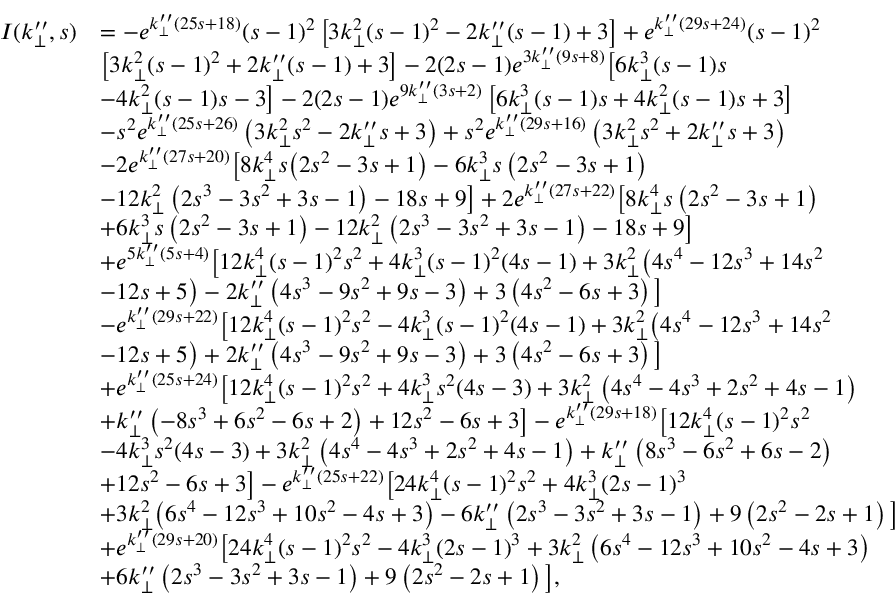Convert formula to latex. <formula><loc_0><loc_0><loc_500><loc_500>\begin{array} { r l } { I ( k _ { \perp } ^ { \prime \prime } , s ) } & { = - e ^ { k _ { \perp } ^ { \prime \prime } ( 2 5 s + 1 8 ) } ( s - 1 ) ^ { 2 } \left [ 3 k _ { \perp } ^ { 2 } ( s - 1 ) ^ { 2 } - 2 k _ { \perp } ^ { \prime \prime } ( s - 1 ) + 3 \right ] + e ^ { k _ { \perp } ^ { \prime \prime } ( 2 9 s + 2 4 ) } ( s - 1 ) ^ { 2 } } \\ & { \left [ 3 k _ { \perp } ^ { 2 } ( s - 1 ) ^ { 2 } + 2 k _ { \perp } ^ { \prime \prime } ( s - 1 ) + 3 \right ] - 2 ( 2 s - 1 ) e ^ { 3 k _ { \perp } ^ { \prime \prime } ( 9 s + 8 ) } \left [ 6 k _ { \perp } ^ { 3 } ( s - 1 ) s } \\ & { - 4 k _ { \perp } ^ { 2 } ( s - 1 ) s - 3 \right ] - 2 ( 2 s - 1 ) e ^ { 9 k _ { \perp } ^ { \prime \prime } ( 3 s + 2 ) } \left [ 6 k _ { \perp } ^ { 3 } ( s - 1 ) s + 4 k _ { \perp } ^ { 2 } ( s - 1 ) s + 3 \right ] } \\ & { - s ^ { 2 } e ^ { k _ { \perp } ^ { \prime \prime } ( 2 5 s + 2 6 ) } \left ( 3 k _ { \perp } ^ { 2 } s ^ { 2 } - 2 k _ { \perp } ^ { \prime \prime } s + 3 \right ) + s ^ { 2 } e ^ { k _ { \perp } ^ { \prime \prime } ( 2 9 s + 1 6 ) } \left ( 3 k _ { \perp } ^ { 2 } s ^ { 2 } + 2 k _ { \perp } ^ { \prime \prime } s + 3 \right ) } \\ & { - 2 e ^ { k _ { \perp } ^ { \prime \prime } ( 2 7 s + 2 0 ) } \left [ 8 k _ { \perp } ^ { 4 } s \left ( 2 s ^ { 2 } - 3 s + 1 \right ) - 6 k _ { \perp } ^ { 3 } s \left ( 2 s ^ { 2 } - 3 s + 1 \right ) } \\ & { - 1 2 k _ { \perp } ^ { 2 } \left ( 2 s ^ { 3 } - 3 s ^ { 2 } + 3 s - 1 \right ) - 1 8 s + 9 \right ] + 2 e ^ { k _ { \perp } ^ { \prime \prime } ( 2 7 s + 2 2 ) } \left [ 8 k _ { \perp } ^ { 4 } s \left ( 2 s ^ { 2 } - 3 s + 1 \right ) } \\ & { + 6 k _ { \perp } ^ { 3 } s \left ( 2 s ^ { 2 } - 3 s + 1 \right ) - 1 2 k _ { \perp } ^ { 2 } \left ( 2 s ^ { 3 } - 3 s ^ { 2 } + 3 s - 1 \right ) - 1 8 s + 9 \right ] } \\ & { + e ^ { 5 k _ { \perp } ^ { \prime \prime } ( 5 s + 4 ) } \left [ 1 2 k _ { \perp } ^ { 4 } ( s - 1 ) ^ { 2 } s ^ { 2 } + 4 k _ { \perp } ^ { 3 } ( s - 1 ) ^ { 2 } ( 4 s - 1 ) + 3 k _ { \perp } ^ { 2 } \left ( 4 s ^ { 4 } - 1 2 s ^ { 3 } + 1 4 s ^ { 2 } } \\ & { - 1 2 s + 5 \right ) - 2 k _ { \perp } ^ { \prime \prime } \left ( 4 s ^ { 3 } - 9 s ^ { 2 } + 9 s - 3 \right ) + 3 \left ( 4 s ^ { 2 } - 6 s + 3 \right ) \right ] } \\ & { - e ^ { k _ { \perp } ^ { \prime \prime } ( 2 9 s + 2 2 ) } \left [ 1 2 k _ { \perp } ^ { 4 } ( s - 1 ) ^ { 2 } s ^ { 2 } - 4 k _ { \perp } ^ { 3 } ( s - 1 ) ^ { 2 } ( 4 s - 1 ) + 3 k _ { \perp } ^ { 2 } \left ( 4 s ^ { 4 } - 1 2 s ^ { 3 } + 1 4 s ^ { 2 } } \\ & { - 1 2 s + 5 \right ) + 2 k _ { \perp } ^ { \prime \prime } \left ( 4 s ^ { 3 } - 9 s ^ { 2 } + 9 s - 3 \right ) + 3 \left ( 4 s ^ { 2 } - 6 s + 3 \right ) \right ] } \\ & { + e ^ { k _ { \perp } ^ { \prime \prime } ( 2 5 s + 2 4 ) } \left [ 1 2 k _ { \perp } ^ { 4 } ( s - 1 ) ^ { 2 } s ^ { 2 } + 4 k _ { \perp } ^ { 3 } s ^ { 2 } ( 4 s - 3 ) + 3 k _ { \perp } ^ { 2 } \left ( 4 s ^ { 4 } - 4 s ^ { 3 } + 2 s ^ { 2 } + 4 s - 1 \right ) } \\ & { + k _ { \perp } ^ { \prime \prime } \left ( - 8 s ^ { 3 } + 6 s ^ { 2 } - 6 s + 2 \right ) + 1 2 s ^ { 2 } - 6 s + 3 \right ] - e ^ { k _ { \perp } ^ { \prime \prime } ( 2 9 s + 1 8 ) } \left [ 1 2 k _ { \perp } ^ { 4 } ( s - 1 ) ^ { 2 } s ^ { 2 } } \\ & { - 4 k _ { \perp } ^ { 3 } s ^ { 2 } ( 4 s - 3 ) + 3 k _ { \perp } ^ { 2 } \left ( 4 s ^ { 4 } - 4 s ^ { 3 } + 2 s ^ { 2 } + 4 s - 1 \right ) + k _ { \perp } ^ { \prime \prime } \left ( 8 s ^ { 3 } - 6 s ^ { 2 } + 6 s - 2 \right ) } \\ & { + 1 2 s ^ { 2 } - 6 s + 3 \right ] - e ^ { k _ { \perp } ^ { \prime \prime } ( 2 5 s + 2 2 ) } \left [ 2 4 k _ { \perp } ^ { 4 } ( s - 1 ) ^ { 2 } s ^ { 2 } + 4 k _ { \perp } ^ { 3 } ( 2 s - 1 ) ^ { 3 } } \\ & { + 3 k _ { \perp } ^ { 2 } \left ( 6 s ^ { 4 } - 1 2 s ^ { 3 } + 1 0 s ^ { 2 } - 4 s + 3 \right ) - 6 k _ { \perp } ^ { \prime \prime } \left ( 2 s ^ { 3 } - 3 s ^ { 2 } + 3 s - 1 \right ) + 9 \left ( 2 s ^ { 2 } - 2 s + 1 \right ) \right ] } \\ & { + e ^ { k _ { \perp } ^ { \prime \prime } ( 2 9 s + 2 0 ) } \left [ 2 4 k _ { \perp } ^ { 4 } ( s - 1 ) ^ { 2 } s ^ { 2 } - 4 k _ { \perp } ^ { 3 } ( 2 s - 1 ) ^ { 3 } + 3 k _ { \perp } ^ { 2 } \left ( 6 s ^ { 4 } - 1 2 s ^ { 3 } + 1 0 s ^ { 2 } - 4 s + 3 \right ) } \\ & { + 6 k _ { \perp } ^ { \prime \prime } \left ( 2 s ^ { 3 } - 3 s ^ { 2 } + 3 s - 1 \right ) + 9 \left ( 2 s ^ { 2 } - 2 s + 1 \right ) \right ] , } \end{array}</formula> 